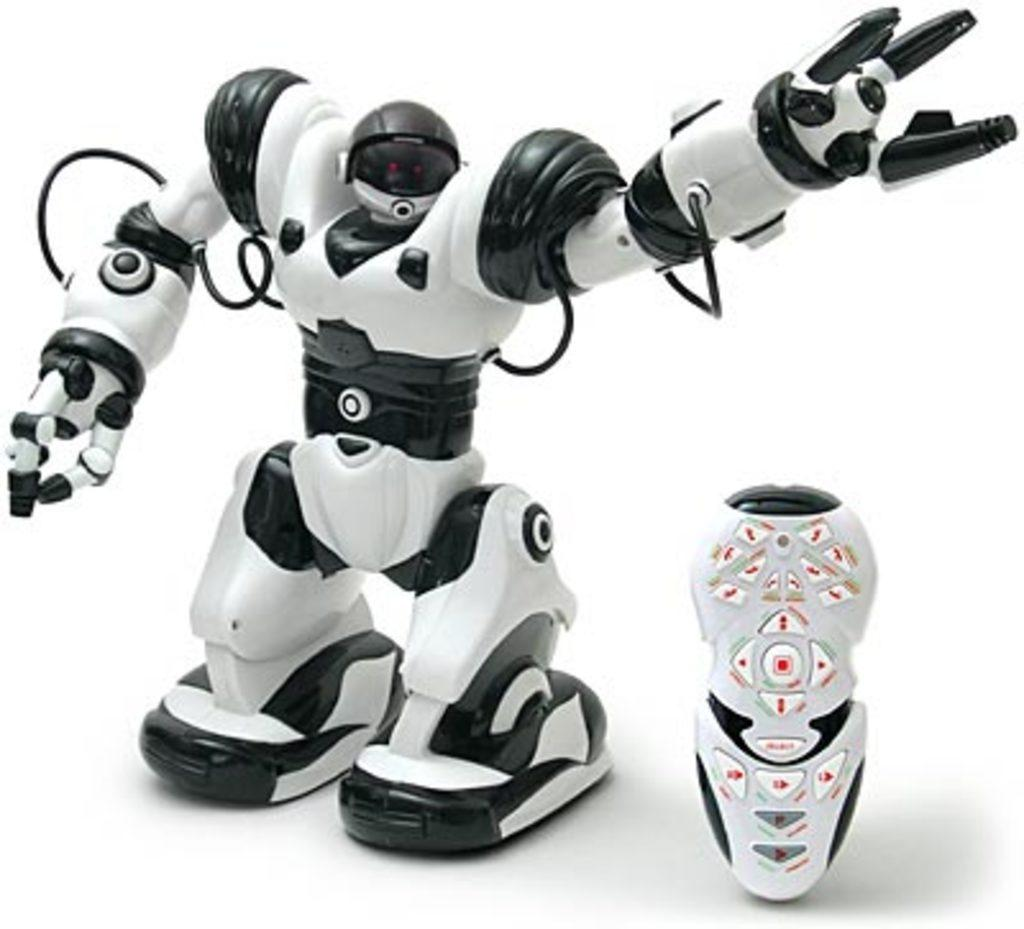What is the main subject of the image? There is a robot in the image. What object is present that might be used to control the robot? There is a remote in the image. Where is the harbor located in the image? There is no harbor present in the image; it features a robot and a remote. What type of art can be seen on the robot's tongue in the image? There is no tongue or art present on the robot in the image. 